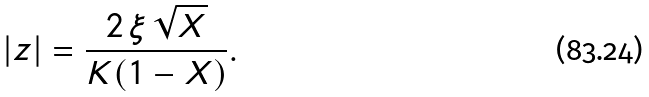<formula> <loc_0><loc_0><loc_500><loc_500>| z | = \frac { 2 \, \xi \, \sqrt { X } } { K ( 1 - X ) } .</formula> 